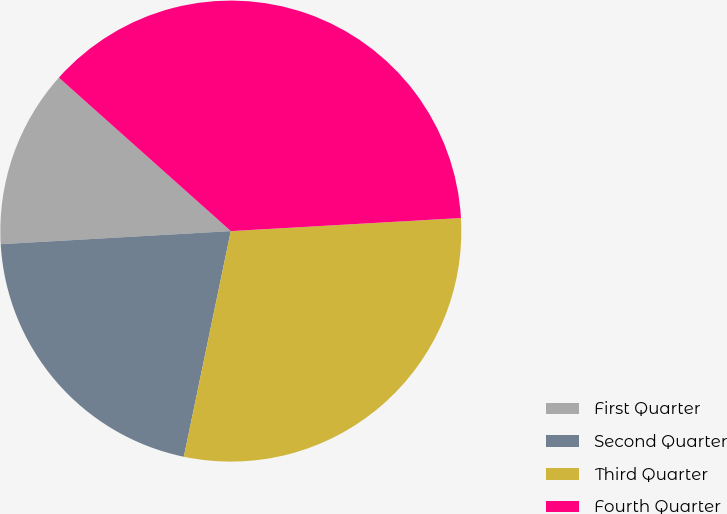Convert chart. <chart><loc_0><loc_0><loc_500><loc_500><pie_chart><fcel>First Quarter<fcel>Second Quarter<fcel>Third Quarter<fcel>Fourth Quarter<nl><fcel>12.5%<fcel>20.83%<fcel>29.17%<fcel>37.5%<nl></chart> 